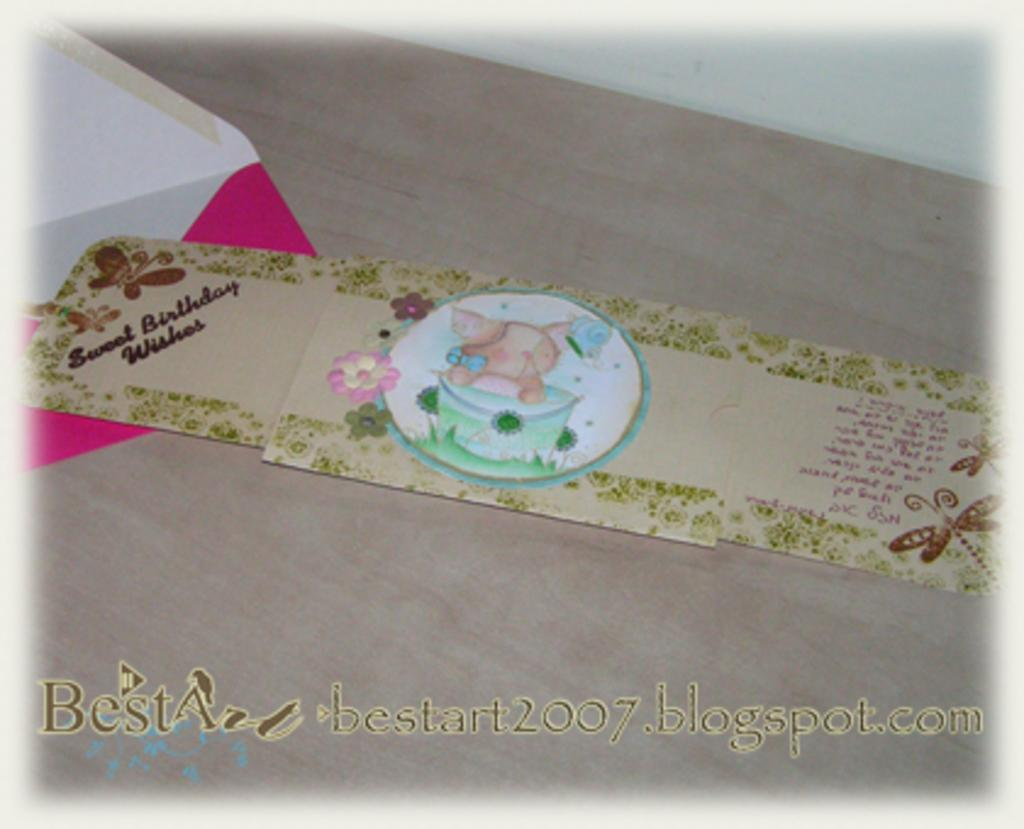<image>
Present a compact description of the photo's key features. A blog on blogspot.com goes by the title Best Art. 